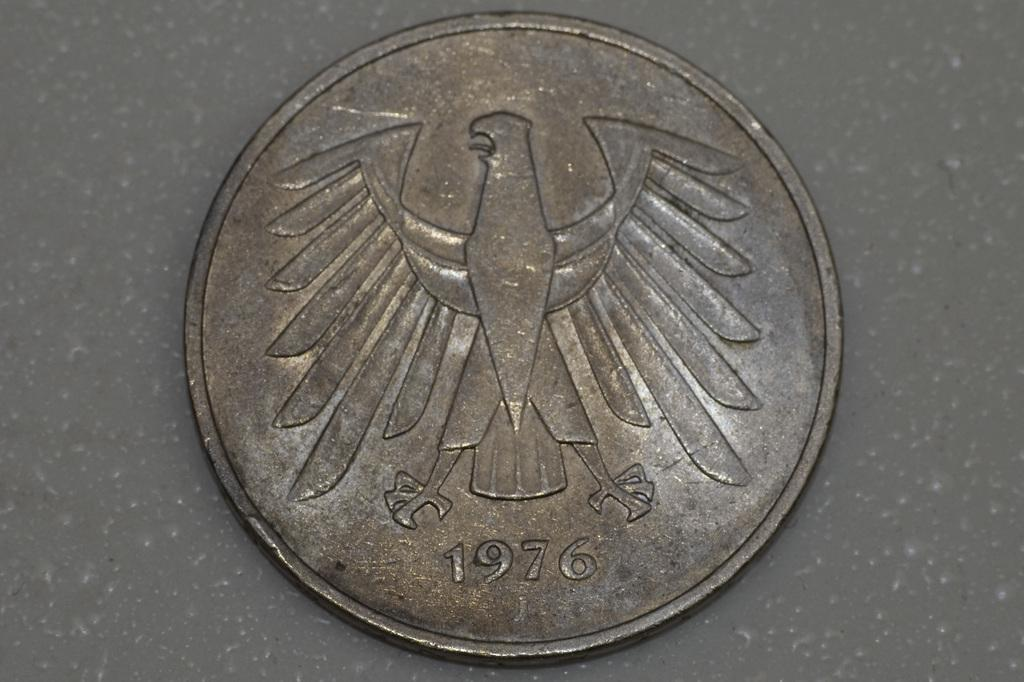<image>
Share a concise interpretation of the image provided. Copper coin showing a bird on it and the year 1976. 